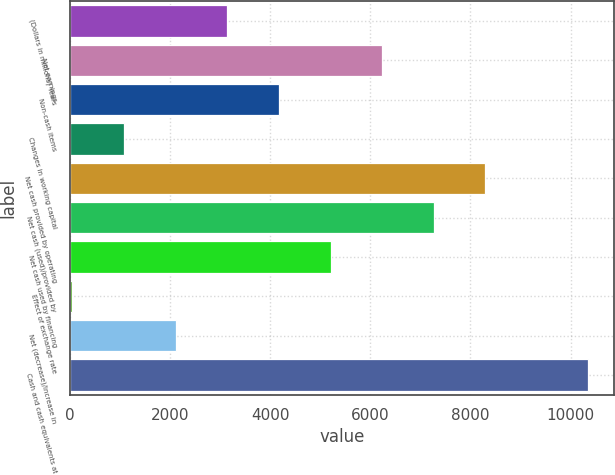Convert chart to OTSL. <chart><loc_0><loc_0><loc_500><loc_500><bar_chart><fcel>(Dollars in millions) Years<fcel>Net earnings<fcel>Non-cash items<fcel>Changes in working capital<fcel>Net cash provided by operating<fcel>Net cash (used)/provided by<fcel>Net cash used by financing<fcel>Effect of exchange rate<fcel>Net (decrease)/increase in<fcel>Cash and cash equivalents at<nl><fcel>3140.4<fcel>6234<fcel>4171.6<fcel>1078<fcel>8296.4<fcel>7265.2<fcel>5202.8<fcel>29<fcel>2109.2<fcel>10358.8<nl></chart> 